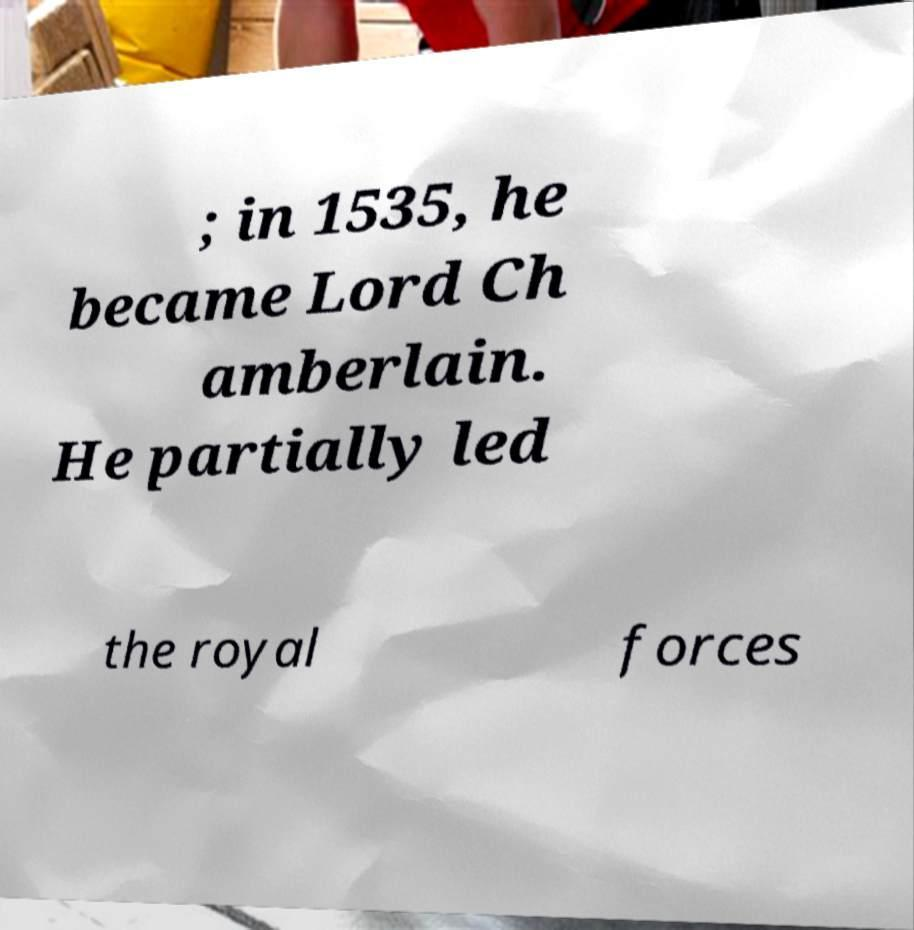Can you accurately transcribe the text from the provided image for me? ; in 1535, he became Lord Ch amberlain. He partially led the royal forces 